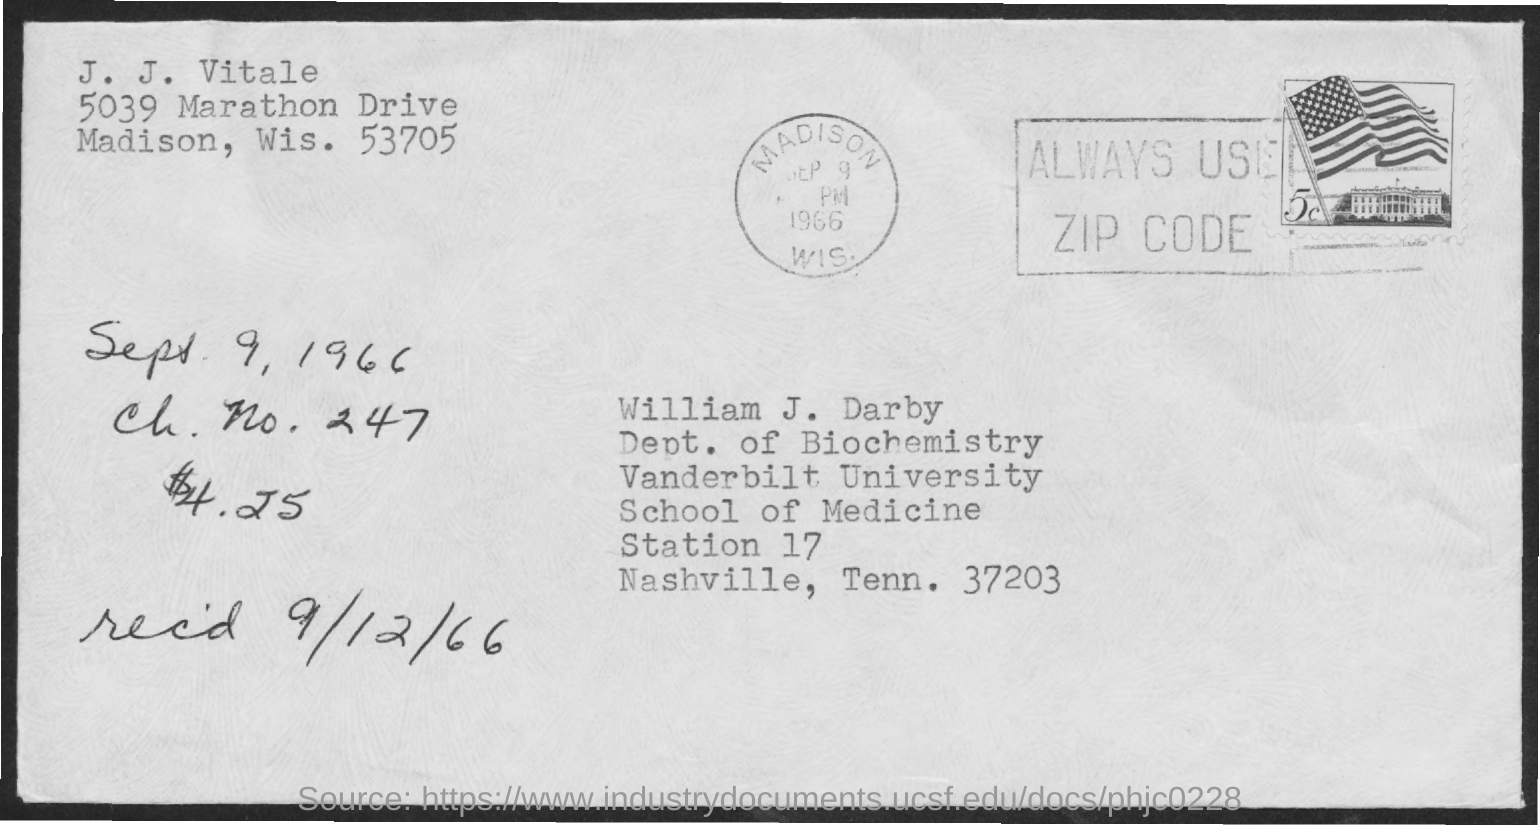Give some essential details in this illustration. What is the number given as 247...? William J. Darby is from Vanderbilt University, as stated in the address. The postal card mentions a received date of 9/12/66. 